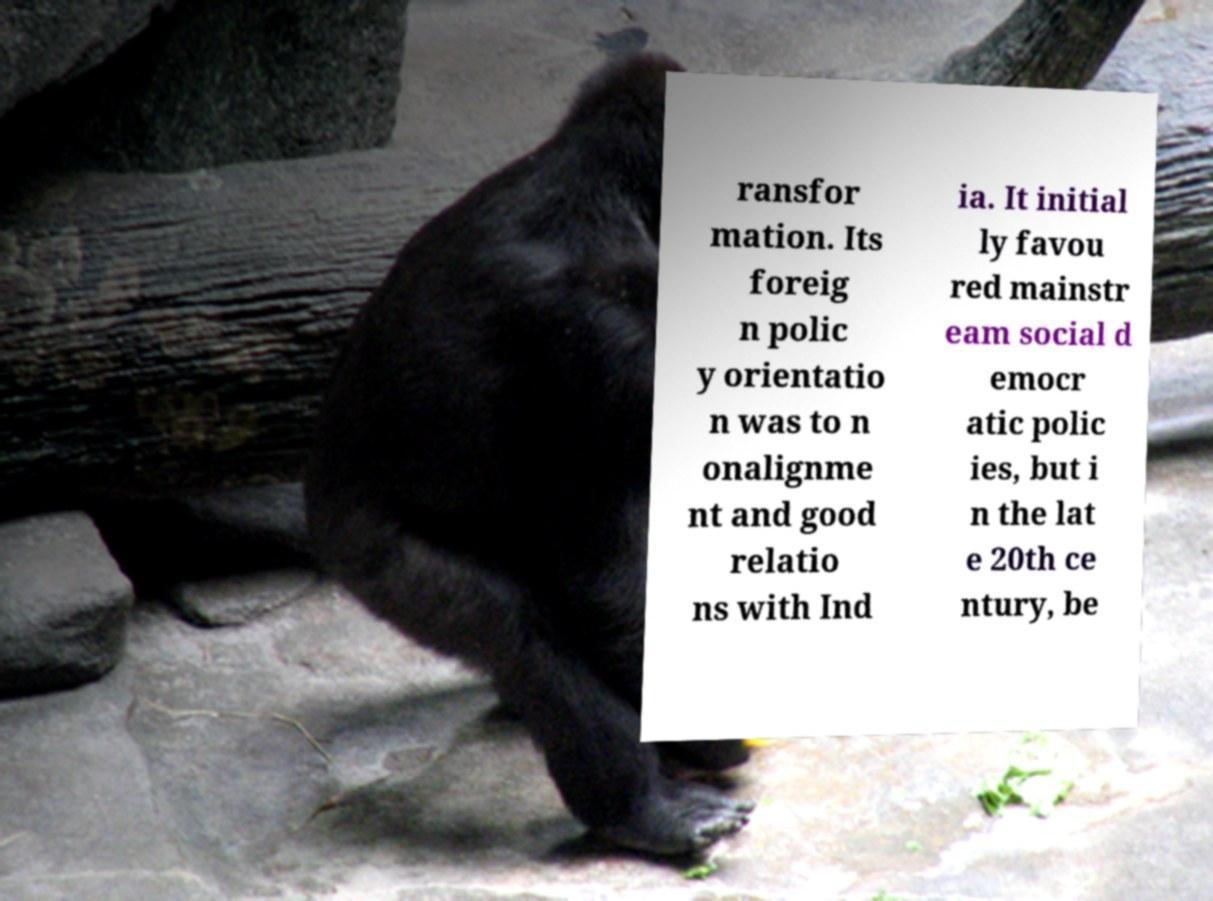Could you assist in decoding the text presented in this image and type it out clearly? ransfor mation. Its foreig n polic y orientatio n was to n onalignme nt and good relatio ns with Ind ia. It initial ly favou red mainstr eam social d emocr atic polic ies, but i n the lat e 20th ce ntury, be 